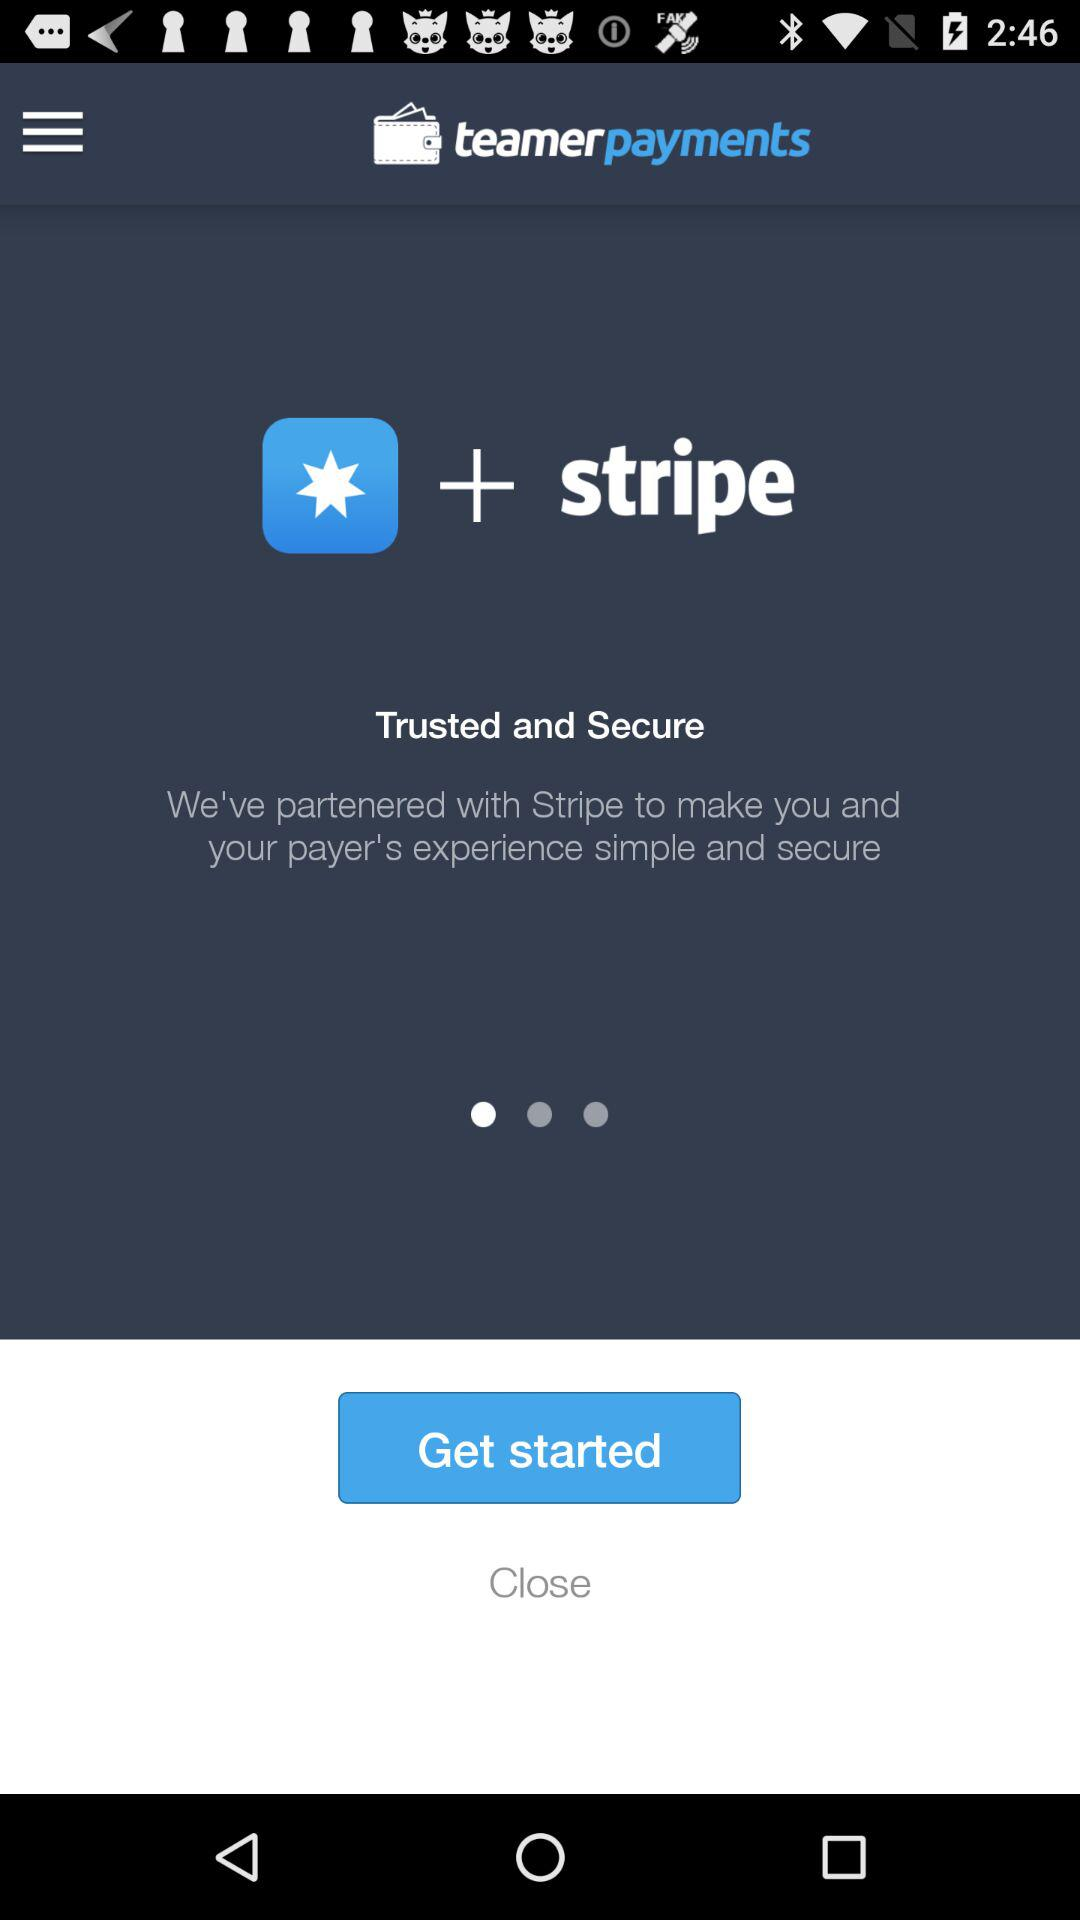What is the app name? The app name is "teamerpayments". 